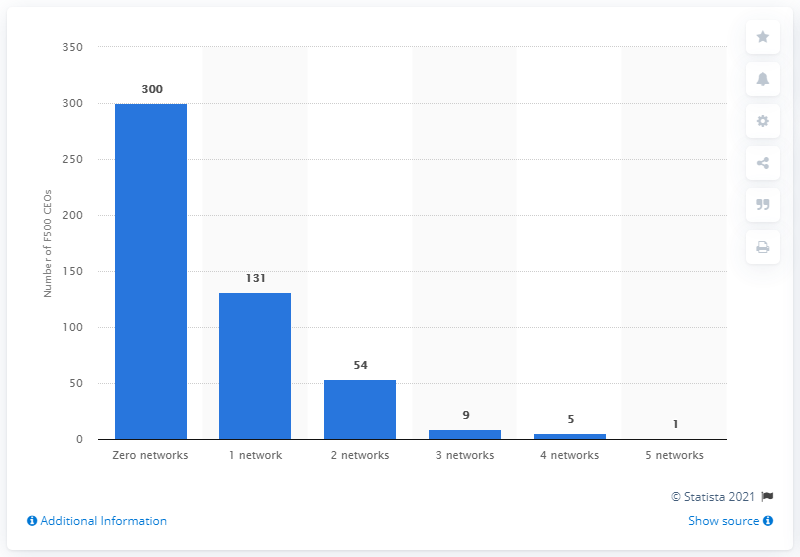Is there a trend that can be observed from the distribution of social media accounts among these CEOs? The chart reveals a clear trend: the number of CEOs decreases significantly as the number of social media accounts increases. A majority of 300 CEOs are not on any social network, followed by 131 CEOs with one network. This suggests that as social media involvement grows, fewer CEOs participate, perhaps indicating a preference for limited or no social media engagement in this professional group. 